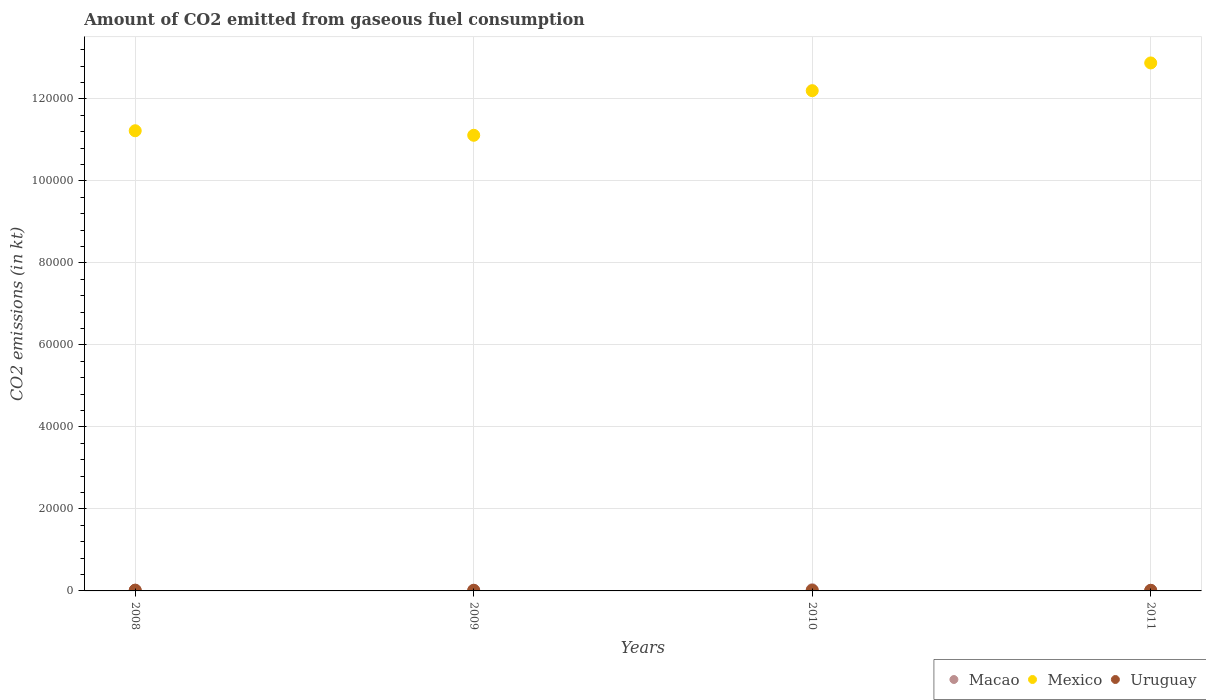Is the number of dotlines equal to the number of legend labels?
Give a very brief answer. Yes. What is the amount of CO2 emitted in Uruguay in 2010?
Give a very brief answer. 132.01. Across all years, what is the maximum amount of CO2 emitted in Mexico?
Ensure brevity in your answer.  1.29e+05. Across all years, what is the minimum amount of CO2 emitted in Uruguay?
Keep it short and to the point. 132.01. In which year was the amount of CO2 emitted in Macao maximum?
Give a very brief answer. 2010. What is the total amount of CO2 emitted in Mexico in the graph?
Your answer should be very brief. 4.74e+05. What is the difference between the amount of CO2 emitted in Macao in 2008 and that in 2011?
Your answer should be compact. 14.67. What is the difference between the amount of CO2 emitted in Macao in 2011 and the amount of CO2 emitted in Uruguay in 2008?
Ensure brevity in your answer.  -47.67. What is the average amount of CO2 emitted in Uruguay per year?
Your answer should be very brief. 150.35. In the year 2008, what is the difference between the amount of CO2 emitted in Uruguay and amount of CO2 emitted in Macao?
Give a very brief answer. 33. What is the ratio of the amount of CO2 emitted in Uruguay in 2008 to that in 2009?
Offer a very short reply. 1.44. Is the amount of CO2 emitted in Mexico in 2008 less than that in 2010?
Provide a succinct answer. Yes. What is the difference between the highest and the second highest amount of CO2 emitted in Macao?
Your response must be concise. 117.34. What is the difference between the highest and the lowest amount of CO2 emitted in Macao?
Ensure brevity in your answer.  154.01. In how many years, is the amount of CO2 emitted in Uruguay greater than the average amount of CO2 emitted in Uruguay taken over all years?
Your answer should be very brief. 1. Is the sum of the amount of CO2 emitted in Uruguay in 2010 and 2011 greater than the maximum amount of CO2 emitted in Mexico across all years?
Ensure brevity in your answer.  No. Is it the case that in every year, the sum of the amount of CO2 emitted in Uruguay and amount of CO2 emitted in Macao  is greater than the amount of CO2 emitted in Mexico?
Keep it short and to the point. No. Is the amount of CO2 emitted in Macao strictly greater than the amount of CO2 emitted in Mexico over the years?
Give a very brief answer. No. Is the amount of CO2 emitted in Uruguay strictly less than the amount of CO2 emitted in Mexico over the years?
Give a very brief answer. Yes. How many dotlines are there?
Provide a short and direct response. 3. Does the graph contain grids?
Provide a succinct answer. Yes. Where does the legend appear in the graph?
Ensure brevity in your answer.  Bottom right. How many legend labels are there?
Your answer should be compact. 3. What is the title of the graph?
Keep it short and to the point. Amount of CO2 emitted from gaseous fuel consumption. Does "Least developed countries" appear as one of the legend labels in the graph?
Your answer should be compact. No. What is the label or title of the X-axis?
Provide a short and direct response. Years. What is the label or title of the Y-axis?
Make the answer very short. CO2 emissions (in kt). What is the CO2 emissions (in kt) in Macao in 2008?
Offer a terse response. 157.68. What is the CO2 emissions (in kt) in Mexico in 2008?
Provide a short and direct response. 1.12e+05. What is the CO2 emissions (in kt) in Uruguay in 2008?
Provide a succinct answer. 190.68. What is the CO2 emissions (in kt) in Macao in 2009?
Offer a terse response. 179.68. What is the CO2 emissions (in kt) in Mexico in 2009?
Offer a terse response. 1.11e+05. What is the CO2 emissions (in kt) of Uruguay in 2009?
Offer a very short reply. 132.01. What is the CO2 emissions (in kt) in Macao in 2010?
Keep it short and to the point. 297.03. What is the CO2 emissions (in kt) of Mexico in 2010?
Your answer should be compact. 1.22e+05. What is the CO2 emissions (in kt) in Uruguay in 2010?
Provide a succinct answer. 132.01. What is the CO2 emissions (in kt) in Macao in 2011?
Make the answer very short. 143.01. What is the CO2 emissions (in kt) in Mexico in 2011?
Your answer should be very brief. 1.29e+05. What is the CO2 emissions (in kt) in Uruguay in 2011?
Provide a succinct answer. 146.68. Across all years, what is the maximum CO2 emissions (in kt) of Macao?
Provide a short and direct response. 297.03. Across all years, what is the maximum CO2 emissions (in kt) in Mexico?
Keep it short and to the point. 1.29e+05. Across all years, what is the maximum CO2 emissions (in kt) in Uruguay?
Keep it short and to the point. 190.68. Across all years, what is the minimum CO2 emissions (in kt) in Macao?
Make the answer very short. 143.01. Across all years, what is the minimum CO2 emissions (in kt) in Mexico?
Your response must be concise. 1.11e+05. Across all years, what is the minimum CO2 emissions (in kt) in Uruguay?
Ensure brevity in your answer.  132.01. What is the total CO2 emissions (in kt) in Macao in the graph?
Your answer should be very brief. 777.4. What is the total CO2 emissions (in kt) of Mexico in the graph?
Your response must be concise. 4.74e+05. What is the total CO2 emissions (in kt) in Uruguay in the graph?
Provide a succinct answer. 601.39. What is the difference between the CO2 emissions (in kt) of Macao in 2008 and that in 2009?
Offer a terse response. -22. What is the difference between the CO2 emissions (in kt) in Mexico in 2008 and that in 2009?
Make the answer very short. 1107.43. What is the difference between the CO2 emissions (in kt) in Uruguay in 2008 and that in 2009?
Provide a short and direct response. 58.67. What is the difference between the CO2 emissions (in kt) of Macao in 2008 and that in 2010?
Offer a very short reply. -139.35. What is the difference between the CO2 emissions (in kt) of Mexico in 2008 and that in 2010?
Provide a succinct answer. -9772.56. What is the difference between the CO2 emissions (in kt) of Uruguay in 2008 and that in 2010?
Give a very brief answer. 58.67. What is the difference between the CO2 emissions (in kt) of Macao in 2008 and that in 2011?
Offer a very short reply. 14.67. What is the difference between the CO2 emissions (in kt) of Mexico in 2008 and that in 2011?
Provide a short and direct response. -1.65e+04. What is the difference between the CO2 emissions (in kt) in Uruguay in 2008 and that in 2011?
Offer a very short reply. 44. What is the difference between the CO2 emissions (in kt) in Macao in 2009 and that in 2010?
Ensure brevity in your answer.  -117.34. What is the difference between the CO2 emissions (in kt) in Mexico in 2009 and that in 2010?
Keep it short and to the point. -1.09e+04. What is the difference between the CO2 emissions (in kt) of Macao in 2009 and that in 2011?
Provide a succinct answer. 36.67. What is the difference between the CO2 emissions (in kt) of Mexico in 2009 and that in 2011?
Give a very brief answer. -1.76e+04. What is the difference between the CO2 emissions (in kt) in Uruguay in 2009 and that in 2011?
Your response must be concise. -14.67. What is the difference between the CO2 emissions (in kt) in Macao in 2010 and that in 2011?
Your response must be concise. 154.01. What is the difference between the CO2 emissions (in kt) in Mexico in 2010 and that in 2011?
Your response must be concise. -6765.61. What is the difference between the CO2 emissions (in kt) of Uruguay in 2010 and that in 2011?
Your answer should be compact. -14.67. What is the difference between the CO2 emissions (in kt) in Macao in 2008 and the CO2 emissions (in kt) in Mexico in 2009?
Your response must be concise. -1.11e+05. What is the difference between the CO2 emissions (in kt) in Macao in 2008 and the CO2 emissions (in kt) in Uruguay in 2009?
Offer a very short reply. 25.67. What is the difference between the CO2 emissions (in kt) of Mexico in 2008 and the CO2 emissions (in kt) of Uruguay in 2009?
Offer a very short reply. 1.12e+05. What is the difference between the CO2 emissions (in kt) of Macao in 2008 and the CO2 emissions (in kt) of Mexico in 2010?
Keep it short and to the point. -1.22e+05. What is the difference between the CO2 emissions (in kt) of Macao in 2008 and the CO2 emissions (in kt) of Uruguay in 2010?
Give a very brief answer. 25.67. What is the difference between the CO2 emissions (in kt) of Mexico in 2008 and the CO2 emissions (in kt) of Uruguay in 2010?
Ensure brevity in your answer.  1.12e+05. What is the difference between the CO2 emissions (in kt) in Macao in 2008 and the CO2 emissions (in kt) in Mexico in 2011?
Ensure brevity in your answer.  -1.29e+05. What is the difference between the CO2 emissions (in kt) of Macao in 2008 and the CO2 emissions (in kt) of Uruguay in 2011?
Provide a short and direct response. 11. What is the difference between the CO2 emissions (in kt) of Mexico in 2008 and the CO2 emissions (in kt) of Uruguay in 2011?
Provide a succinct answer. 1.12e+05. What is the difference between the CO2 emissions (in kt) of Macao in 2009 and the CO2 emissions (in kt) of Mexico in 2010?
Provide a short and direct response. -1.22e+05. What is the difference between the CO2 emissions (in kt) in Macao in 2009 and the CO2 emissions (in kt) in Uruguay in 2010?
Give a very brief answer. 47.67. What is the difference between the CO2 emissions (in kt) of Mexico in 2009 and the CO2 emissions (in kt) of Uruguay in 2010?
Give a very brief answer. 1.11e+05. What is the difference between the CO2 emissions (in kt) of Macao in 2009 and the CO2 emissions (in kt) of Mexico in 2011?
Provide a succinct answer. -1.29e+05. What is the difference between the CO2 emissions (in kt) of Macao in 2009 and the CO2 emissions (in kt) of Uruguay in 2011?
Offer a terse response. 33. What is the difference between the CO2 emissions (in kt) of Mexico in 2009 and the CO2 emissions (in kt) of Uruguay in 2011?
Provide a short and direct response. 1.11e+05. What is the difference between the CO2 emissions (in kt) of Macao in 2010 and the CO2 emissions (in kt) of Mexico in 2011?
Your answer should be compact. -1.28e+05. What is the difference between the CO2 emissions (in kt) in Macao in 2010 and the CO2 emissions (in kt) in Uruguay in 2011?
Keep it short and to the point. 150.35. What is the difference between the CO2 emissions (in kt) in Mexico in 2010 and the CO2 emissions (in kt) in Uruguay in 2011?
Give a very brief answer. 1.22e+05. What is the average CO2 emissions (in kt) in Macao per year?
Keep it short and to the point. 194.35. What is the average CO2 emissions (in kt) in Mexico per year?
Provide a succinct answer. 1.19e+05. What is the average CO2 emissions (in kt) of Uruguay per year?
Ensure brevity in your answer.  150.35. In the year 2008, what is the difference between the CO2 emissions (in kt) of Macao and CO2 emissions (in kt) of Mexico?
Ensure brevity in your answer.  -1.12e+05. In the year 2008, what is the difference between the CO2 emissions (in kt) in Macao and CO2 emissions (in kt) in Uruguay?
Provide a succinct answer. -33. In the year 2008, what is the difference between the CO2 emissions (in kt) in Mexico and CO2 emissions (in kt) in Uruguay?
Give a very brief answer. 1.12e+05. In the year 2009, what is the difference between the CO2 emissions (in kt) of Macao and CO2 emissions (in kt) of Mexico?
Provide a succinct answer. -1.11e+05. In the year 2009, what is the difference between the CO2 emissions (in kt) of Macao and CO2 emissions (in kt) of Uruguay?
Provide a short and direct response. 47.67. In the year 2009, what is the difference between the CO2 emissions (in kt) in Mexico and CO2 emissions (in kt) in Uruguay?
Make the answer very short. 1.11e+05. In the year 2010, what is the difference between the CO2 emissions (in kt) of Macao and CO2 emissions (in kt) of Mexico?
Make the answer very short. -1.22e+05. In the year 2010, what is the difference between the CO2 emissions (in kt) of Macao and CO2 emissions (in kt) of Uruguay?
Keep it short and to the point. 165.01. In the year 2010, what is the difference between the CO2 emissions (in kt) in Mexico and CO2 emissions (in kt) in Uruguay?
Provide a short and direct response. 1.22e+05. In the year 2011, what is the difference between the CO2 emissions (in kt) of Macao and CO2 emissions (in kt) of Mexico?
Your answer should be very brief. -1.29e+05. In the year 2011, what is the difference between the CO2 emissions (in kt) of Macao and CO2 emissions (in kt) of Uruguay?
Offer a very short reply. -3.67. In the year 2011, what is the difference between the CO2 emissions (in kt) of Mexico and CO2 emissions (in kt) of Uruguay?
Your answer should be compact. 1.29e+05. What is the ratio of the CO2 emissions (in kt) of Macao in 2008 to that in 2009?
Keep it short and to the point. 0.88. What is the ratio of the CO2 emissions (in kt) of Mexico in 2008 to that in 2009?
Offer a very short reply. 1.01. What is the ratio of the CO2 emissions (in kt) in Uruguay in 2008 to that in 2009?
Give a very brief answer. 1.44. What is the ratio of the CO2 emissions (in kt) of Macao in 2008 to that in 2010?
Keep it short and to the point. 0.53. What is the ratio of the CO2 emissions (in kt) in Mexico in 2008 to that in 2010?
Offer a very short reply. 0.92. What is the ratio of the CO2 emissions (in kt) of Uruguay in 2008 to that in 2010?
Your response must be concise. 1.44. What is the ratio of the CO2 emissions (in kt) of Macao in 2008 to that in 2011?
Your response must be concise. 1.1. What is the ratio of the CO2 emissions (in kt) in Mexico in 2008 to that in 2011?
Your answer should be very brief. 0.87. What is the ratio of the CO2 emissions (in kt) of Macao in 2009 to that in 2010?
Make the answer very short. 0.6. What is the ratio of the CO2 emissions (in kt) in Mexico in 2009 to that in 2010?
Provide a short and direct response. 0.91. What is the ratio of the CO2 emissions (in kt) of Uruguay in 2009 to that in 2010?
Your response must be concise. 1. What is the ratio of the CO2 emissions (in kt) in Macao in 2009 to that in 2011?
Your answer should be very brief. 1.26. What is the ratio of the CO2 emissions (in kt) in Mexico in 2009 to that in 2011?
Offer a terse response. 0.86. What is the ratio of the CO2 emissions (in kt) of Uruguay in 2009 to that in 2011?
Your answer should be very brief. 0.9. What is the ratio of the CO2 emissions (in kt) in Macao in 2010 to that in 2011?
Provide a succinct answer. 2.08. What is the ratio of the CO2 emissions (in kt) of Mexico in 2010 to that in 2011?
Give a very brief answer. 0.95. What is the difference between the highest and the second highest CO2 emissions (in kt) in Macao?
Provide a succinct answer. 117.34. What is the difference between the highest and the second highest CO2 emissions (in kt) in Mexico?
Keep it short and to the point. 6765.61. What is the difference between the highest and the second highest CO2 emissions (in kt) of Uruguay?
Offer a very short reply. 44. What is the difference between the highest and the lowest CO2 emissions (in kt) of Macao?
Your answer should be compact. 154.01. What is the difference between the highest and the lowest CO2 emissions (in kt) of Mexico?
Your response must be concise. 1.76e+04. What is the difference between the highest and the lowest CO2 emissions (in kt) of Uruguay?
Keep it short and to the point. 58.67. 